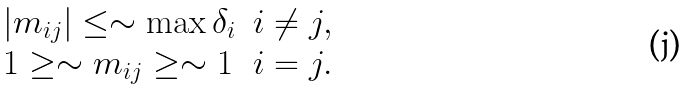Convert formula to latex. <formula><loc_0><loc_0><loc_500><loc_500>\begin{array} { l l } | m _ { i j } | \leq \sim \max \delta _ { i } & i \neq j , \\ 1 \geq \sim m _ { i j } \geq \sim 1 & i = j . \end{array}</formula> 